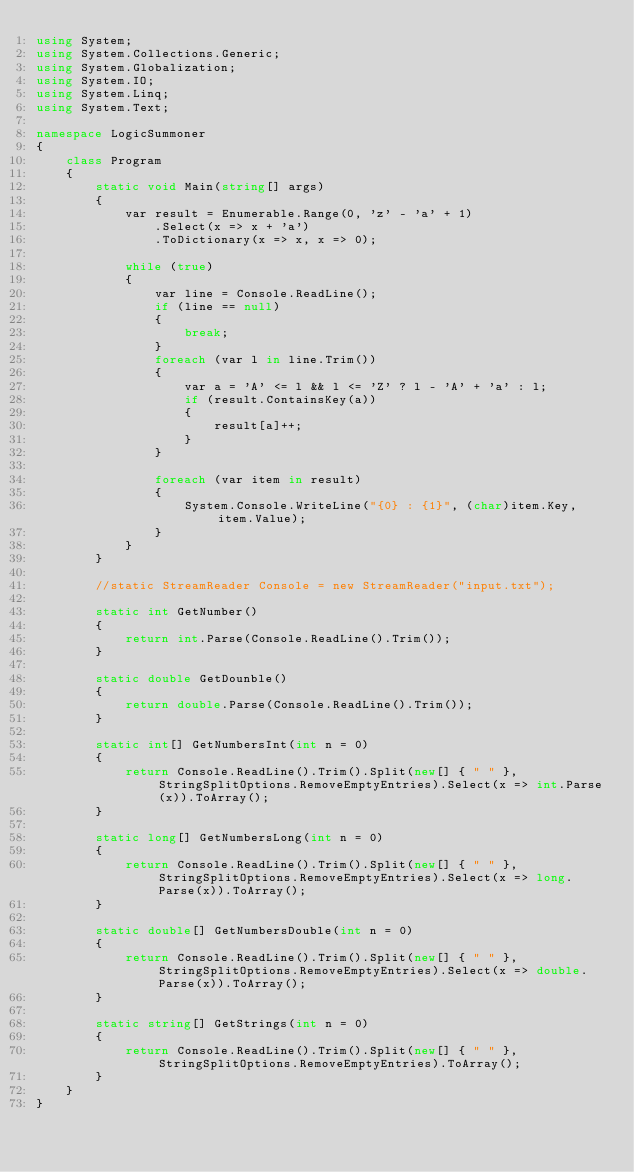<code> <loc_0><loc_0><loc_500><loc_500><_C#_>using System;
using System.Collections.Generic;
using System.Globalization;
using System.IO;
using System.Linq;
using System.Text;

namespace LogicSummoner
{
    class Program
    {
        static void Main(string[] args)
        {
            var result = Enumerable.Range(0, 'z' - 'a' + 1)
                .Select(x => x + 'a')
                .ToDictionary(x => x, x => 0);

            while (true)
            {
                var line = Console.ReadLine();
                if (line == null)
                {
                    break;
                }
                foreach (var l in line.Trim())
                {
                    var a = 'A' <= l && l <= 'Z' ? l - 'A' + 'a' : l;
                    if (result.ContainsKey(a))
                    {
                        result[a]++;
                    }
                }

                foreach (var item in result)
                {
                    System.Console.WriteLine("{0} : {1}", (char)item.Key, item.Value);
                }
            }
        }

        //static StreamReader Console = new StreamReader("input.txt");

        static int GetNumber()
        {
            return int.Parse(Console.ReadLine().Trim());
        }

        static double GetDounble()
        {
            return double.Parse(Console.ReadLine().Trim());
        }

        static int[] GetNumbersInt(int n = 0)
        {
            return Console.ReadLine().Trim().Split(new[] { " " }, StringSplitOptions.RemoveEmptyEntries).Select(x => int.Parse(x)).ToArray();
        }

        static long[] GetNumbersLong(int n = 0)
        {
            return Console.ReadLine().Trim().Split(new[] { " " }, StringSplitOptions.RemoveEmptyEntries).Select(x => long.Parse(x)).ToArray();
        }

        static double[] GetNumbersDouble(int n = 0)
        {
            return Console.ReadLine().Trim().Split(new[] { " " }, StringSplitOptions.RemoveEmptyEntries).Select(x => double.Parse(x)).ToArray();
        }

        static string[] GetStrings(int n = 0)
        {
            return Console.ReadLine().Trim().Split(new[] { " " }, StringSplitOptions.RemoveEmptyEntries).ToArray();
        }
    }
}</code> 